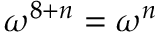<formula> <loc_0><loc_0><loc_500><loc_500>\omega ^ { 8 + n } = \omega ^ { n }</formula> 